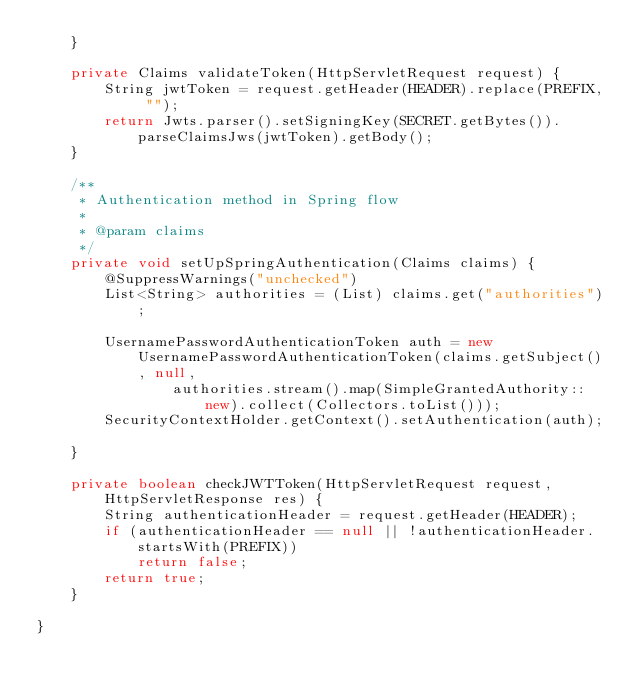Convert code to text. <code><loc_0><loc_0><loc_500><loc_500><_Java_>	}

	private Claims validateToken(HttpServletRequest request) {
		String jwtToken = request.getHeader(HEADER).replace(PREFIX, "");
		return Jwts.parser().setSigningKey(SECRET.getBytes()).parseClaimsJws(jwtToken).getBody();
	}

	/**
	 * Authentication method in Spring flow
	 *
	 * @param claims
	 */
	private void setUpSpringAuthentication(Claims claims) {
		@SuppressWarnings("unchecked")
		List<String> authorities = (List) claims.get("authorities");

		UsernamePasswordAuthenticationToken auth = new UsernamePasswordAuthenticationToken(claims.getSubject(), null,
				authorities.stream().map(SimpleGrantedAuthority::new).collect(Collectors.toList()));
		SecurityContextHolder.getContext().setAuthentication(auth);

	}

	private boolean checkJWTToken(HttpServletRequest request, HttpServletResponse res) {
		String authenticationHeader = request.getHeader(HEADER);
		if (authenticationHeader == null || !authenticationHeader.startsWith(PREFIX))
			return false;
		return true;
	}

}
</code> 